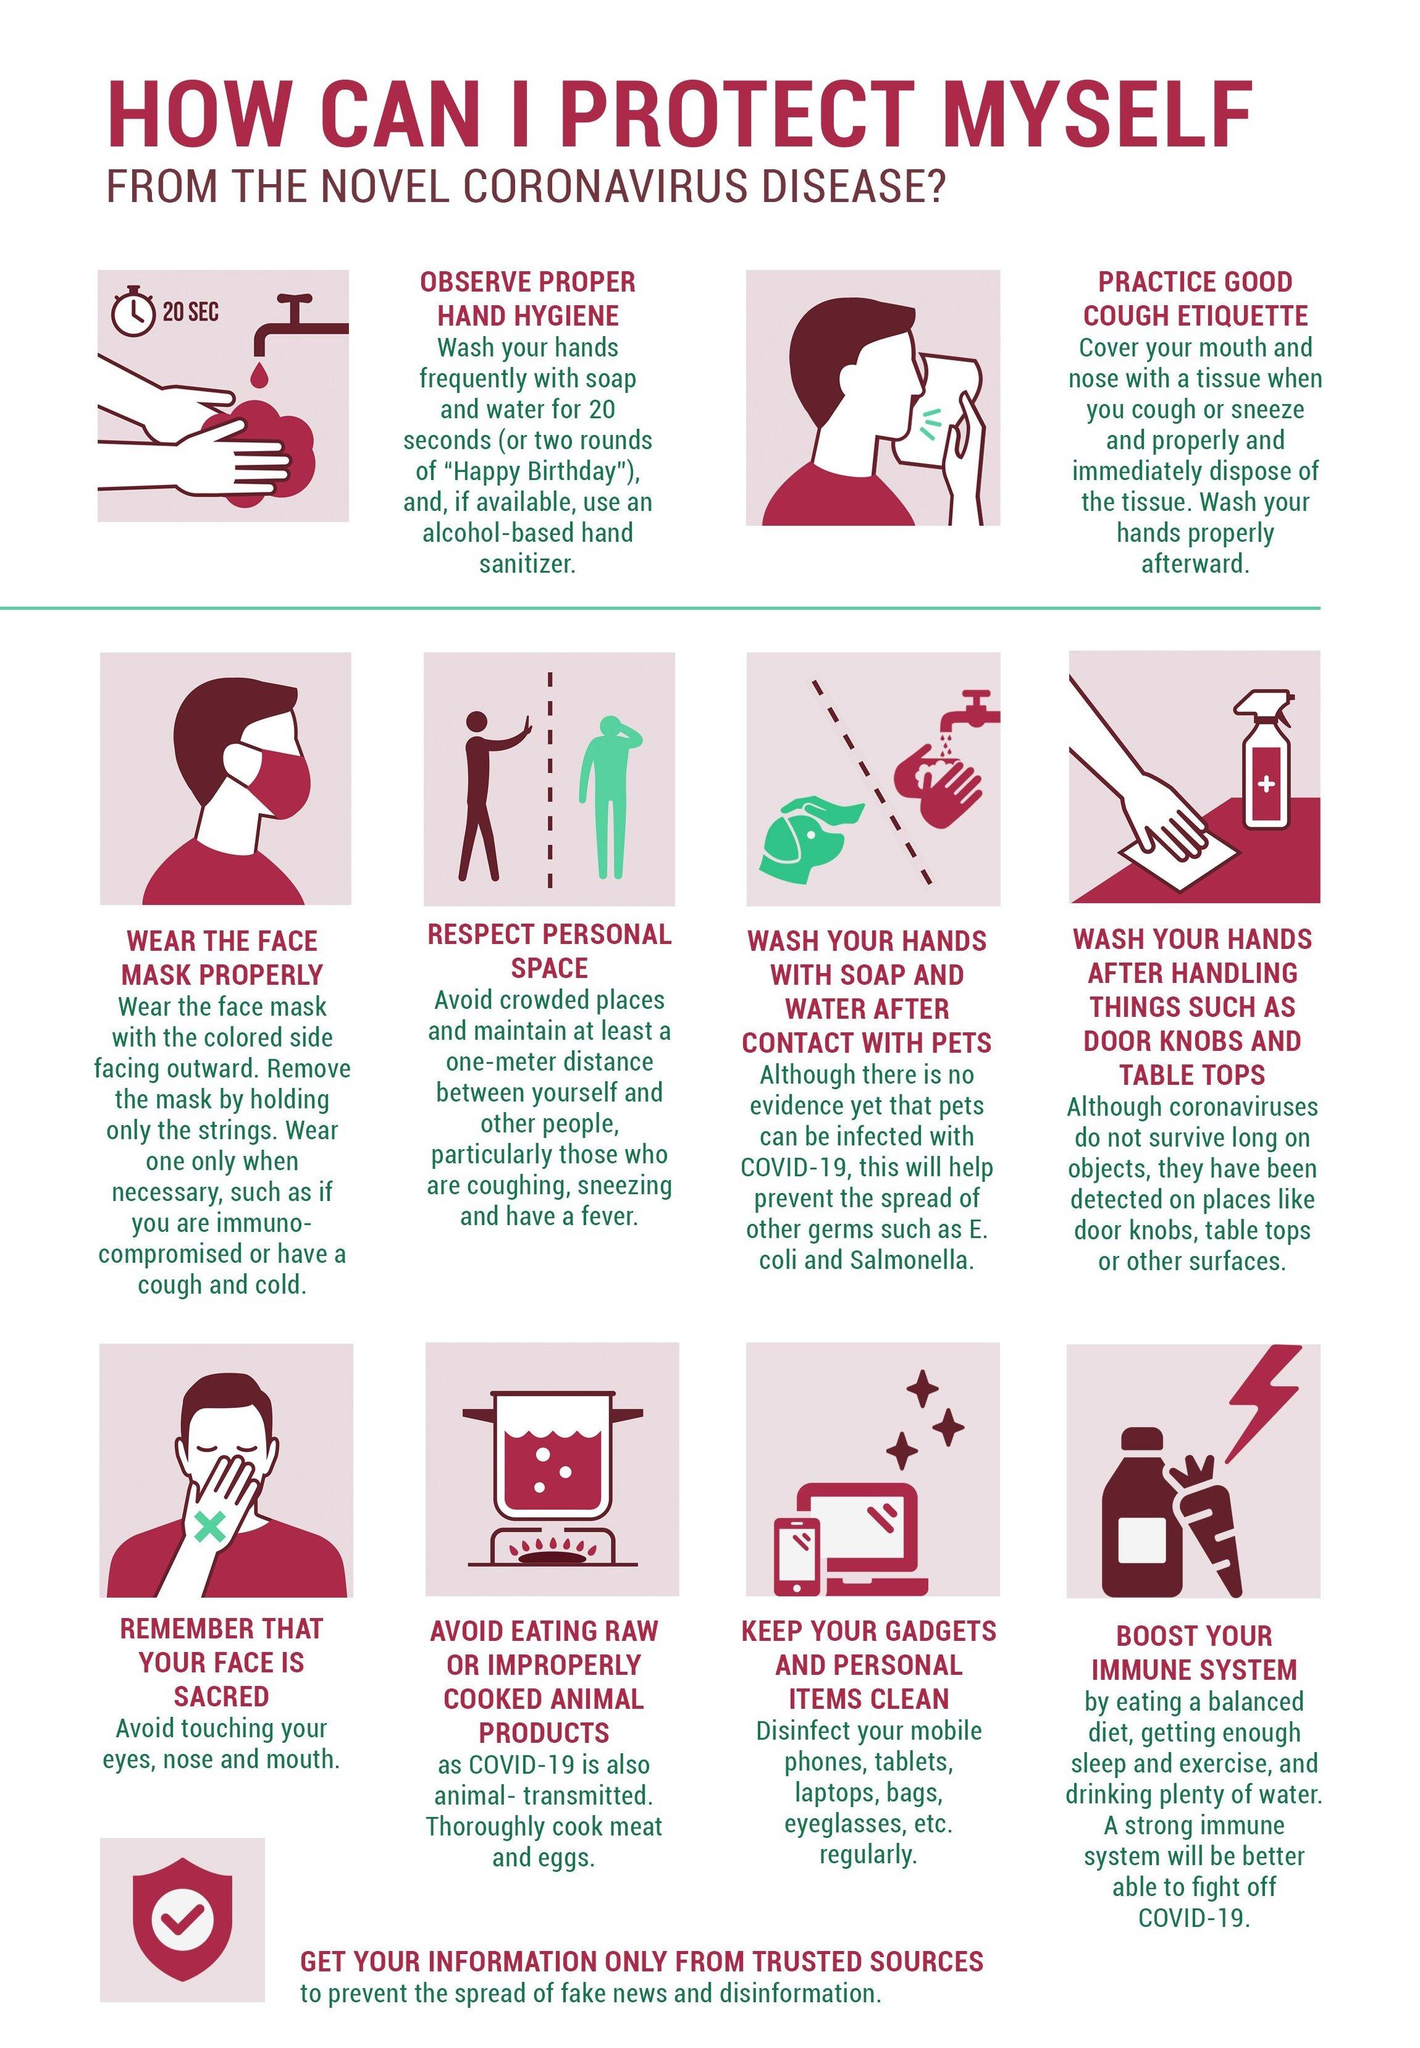List a handful of essential elements in this visual. It is reported that there are individuals wearing masks, with a number ranging from 1 to... There is only one sanitizer included in this infographic. This infographic mentions 3 gadgets. 